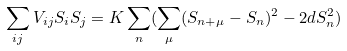<formula> <loc_0><loc_0><loc_500><loc_500>\sum _ { i j } V _ { i j } S _ { i } S _ { j } = K \sum _ { n } ( \sum _ { \mu } ( S _ { n + \mu } - S _ { n } ) ^ { 2 } - 2 d S _ { n } ^ { 2 } )</formula> 